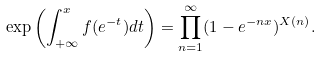Convert formula to latex. <formula><loc_0><loc_0><loc_500><loc_500>\exp \left ( \int ^ { x } _ { + \infty } f ( e ^ { - t } ) d t \right ) = \prod ^ { \infty } _ { n = 1 } ( 1 - e ^ { - n x } ) ^ { X ( n ) } .</formula> 